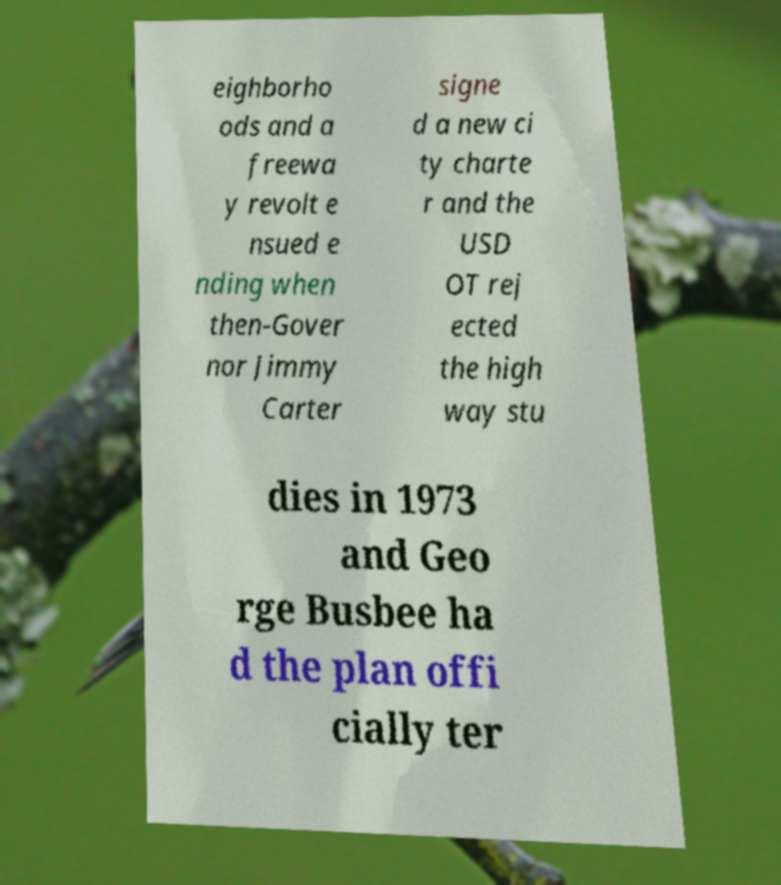What messages or text are displayed in this image? I need them in a readable, typed format. eighborho ods and a freewa y revolt e nsued e nding when then-Gover nor Jimmy Carter signe d a new ci ty charte r and the USD OT rej ected the high way stu dies in 1973 and Geo rge Busbee ha d the plan offi cially ter 